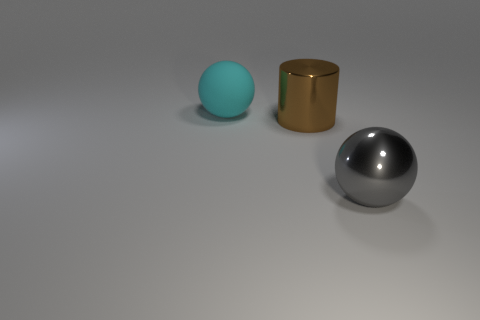There is a cyan rubber object; is it the same shape as the object right of the metallic cylinder?
Provide a short and direct response. Yes. The metallic object that is the same shape as the rubber thing is what size?
Your answer should be very brief. Large. Are there more rubber balls than large balls?
Offer a terse response. No. Do the big matte object and the gray thing have the same shape?
Provide a succinct answer. Yes. What material is the large sphere left of the object that is to the right of the brown shiny cylinder?
Offer a very short reply. Rubber. Is the cyan rubber sphere the same size as the cylinder?
Your answer should be compact. Yes. There is a ball to the left of the large gray metal ball; is there a cyan ball that is to the left of it?
Keep it short and to the point. No. What is the shape of the large metal object that is on the right side of the large brown metallic cylinder?
Your answer should be compact. Sphere. There is a large sphere that is behind the metal object that is behind the big gray shiny ball; what number of balls are on the right side of it?
Make the answer very short. 1. What number of big gray balls have the same material as the brown object?
Offer a very short reply. 1. 